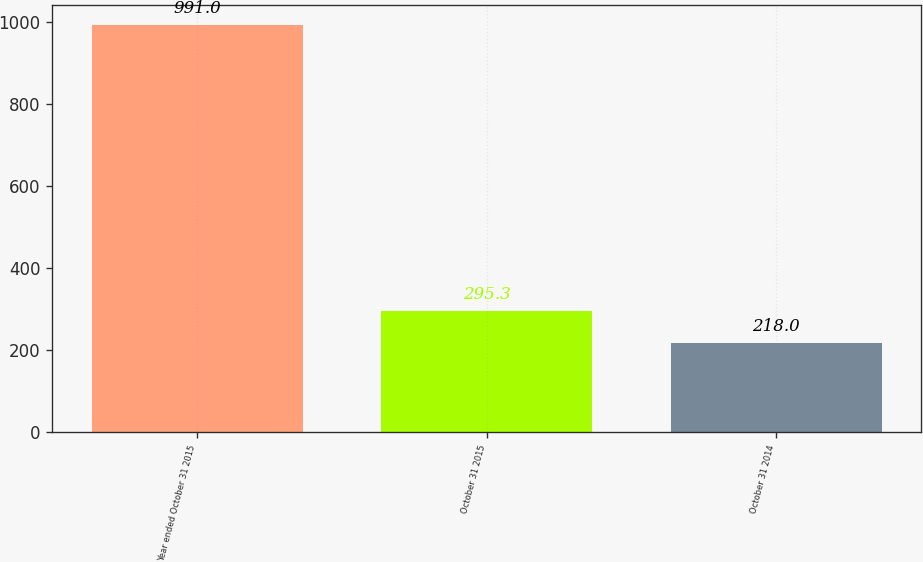Convert chart to OTSL. <chart><loc_0><loc_0><loc_500><loc_500><bar_chart><fcel>Year ended October 31 2015<fcel>October 31 2015<fcel>October 31 2014<nl><fcel>991<fcel>295.3<fcel>218<nl></chart> 